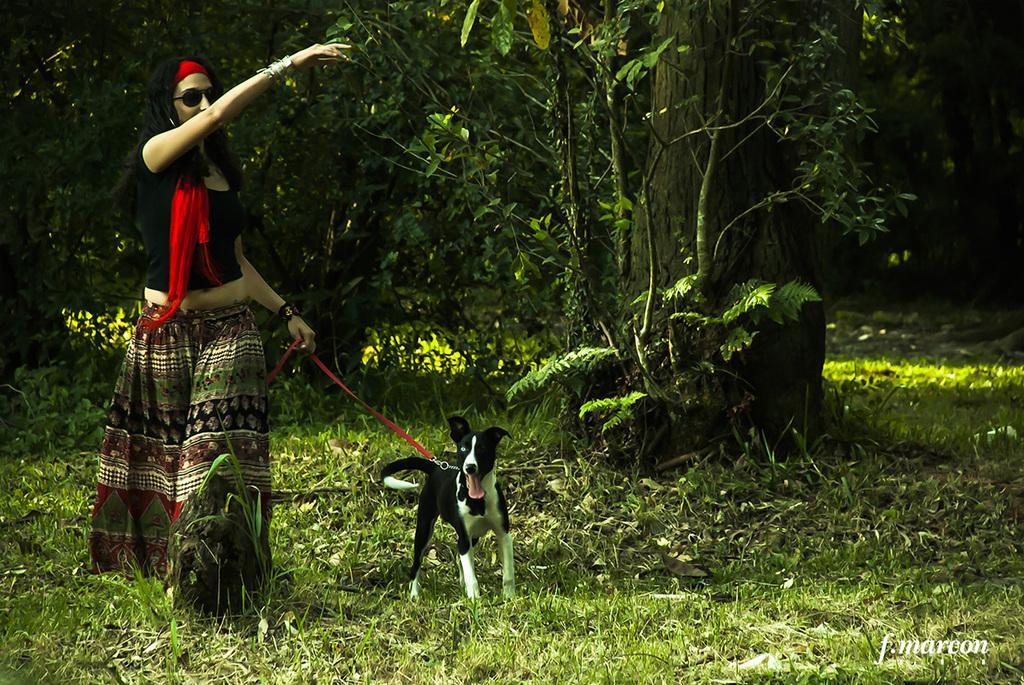Can you describe this image briefly? On the left side of the picture there is a woman walking holding a dog. In the foreground there are plants and grass. In the background there are trees. 